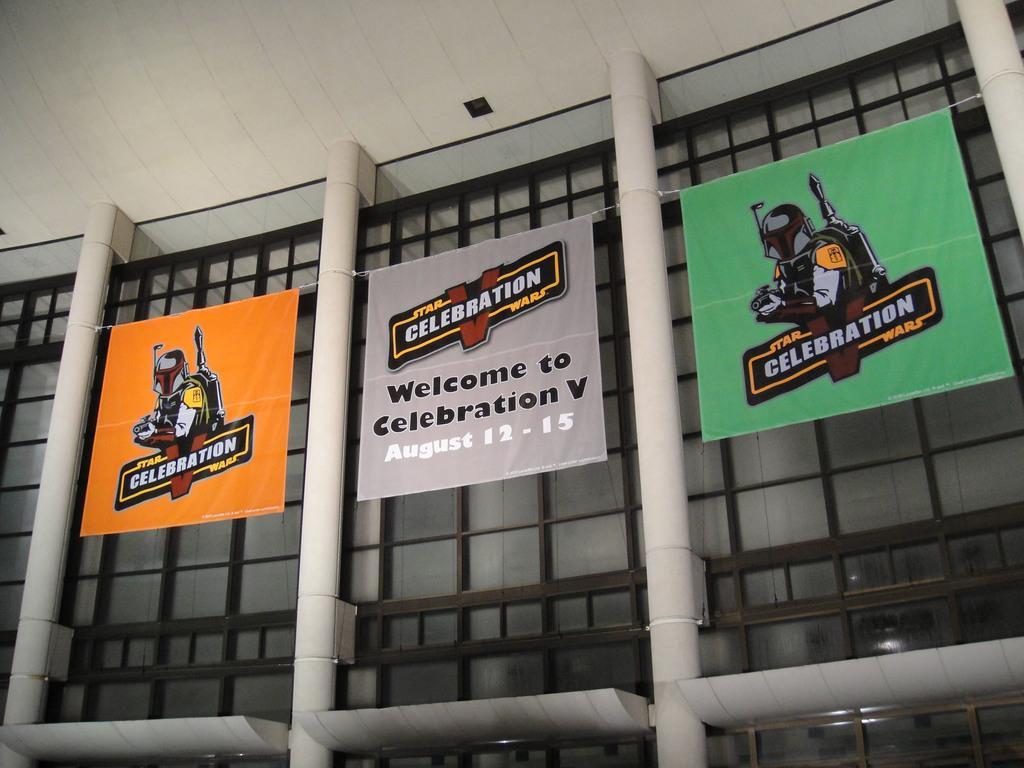Can you describe this image briefly? In this image I can see there are a few banners attached to the pillars by a rope, there are few glasses attached to the window. 